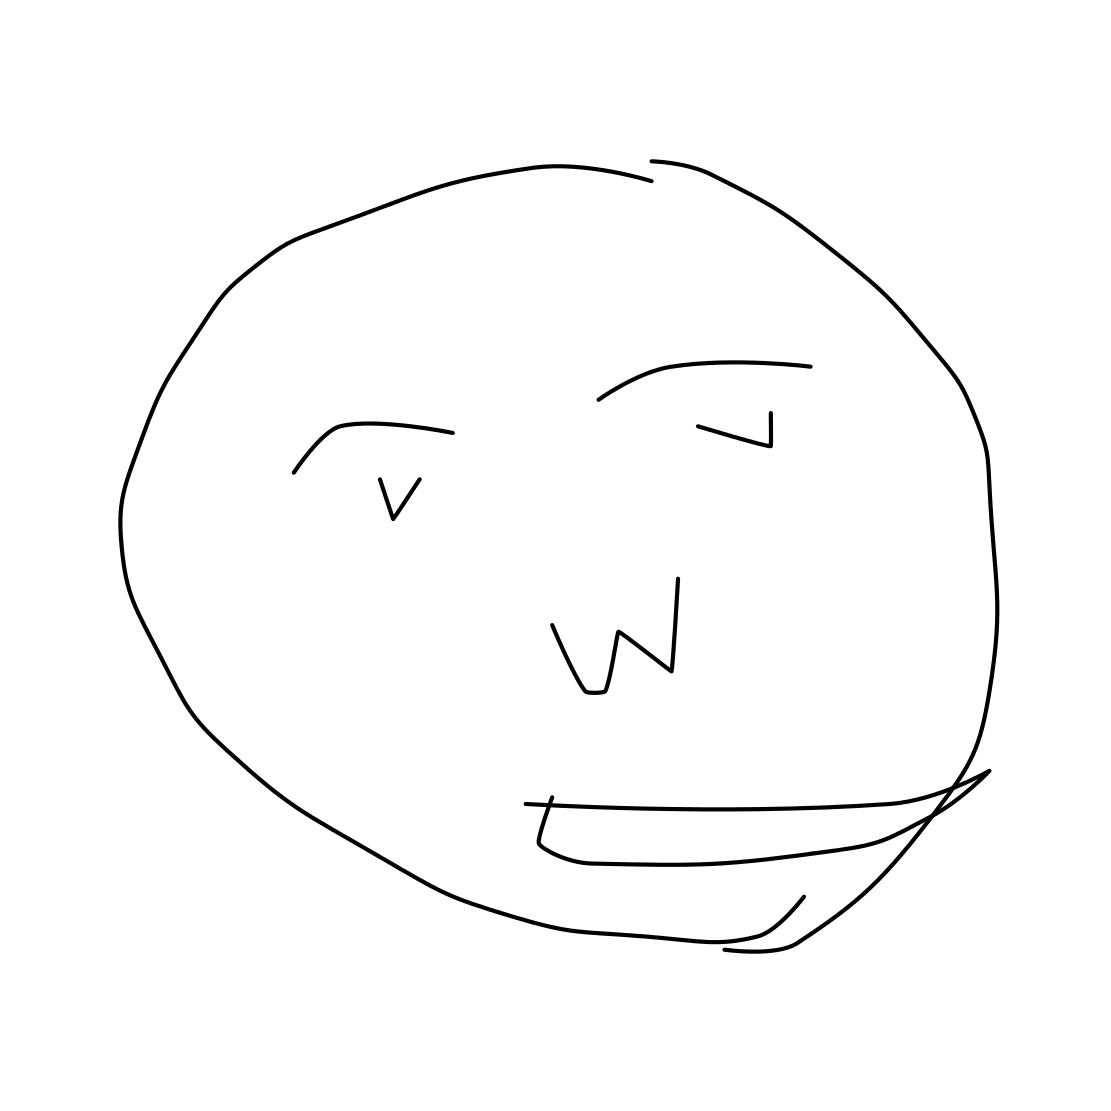Is this a face in the image? Yes 